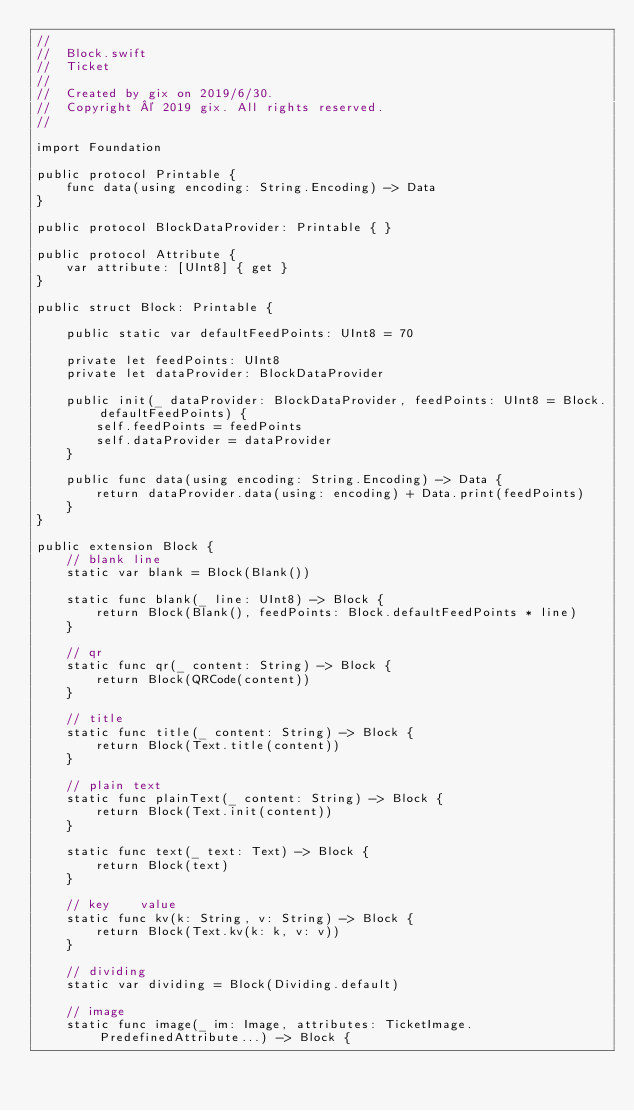<code> <loc_0><loc_0><loc_500><loc_500><_Swift_>//
//  Block.swift
//  Ticket
//
//  Created by gix on 2019/6/30.
//  Copyright © 2019 gix. All rights reserved.
//

import Foundation

public protocol Printable {
    func data(using encoding: String.Encoding) -> Data
}

public protocol BlockDataProvider: Printable { }

public protocol Attribute {
    var attribute: [UInt8] { get }
}

public struct Block: Printable {

    public static var defaultFeedPoints: UInt8 = 70
    
    private let feedPoints: UInt8
    private let dataProvider: BlockDataProvider
    
    public init(_ dataProvider: BlockDataProvider, feedPoints: UInt8 = Block.defaultFeedPoints) {
        self.feedPoints = feedPoints
        self.dataProvider = dataProvider
    }
    
    public func data(using encoding: String.Encoding) -> Data {
        return dataProvider.data(using: encoding) + Data.print(feedPoints)
    }
}

public extension Block {
    // blank line
    static var blank = Block(Blank())
    
    static func blank(_ line: UInt8) -> Block {
        return Block(Blank(), feedPoints: Block.defaultFeedPoints * line)
    }
    
    // qr
    static func qr(_ content: String) -> Block {
        return Block(QRCode(content))
    }
    
    // title
    static func title(_ content: String) -> Block {
        return Block(Text.title(content))
    }
    
    // plain text
    static func plainText(_ content: String) -> Block {
        return Block(Text.init(content))
    }
    
    static func text(_ text: Text) -> Block {
        return Block(text)
    }
    
    // key    value
    static func kv(k: String, v: String) -> Block {
        return Block(Text.kv(k: k, v: v))
    }
    
    // dividing
    static var dividing = Block(Dividing.default)
    
    // image
    static func image(_ im: Image, attributes: TicketImage.PredefinedAttribute...) -> Block {</code> 